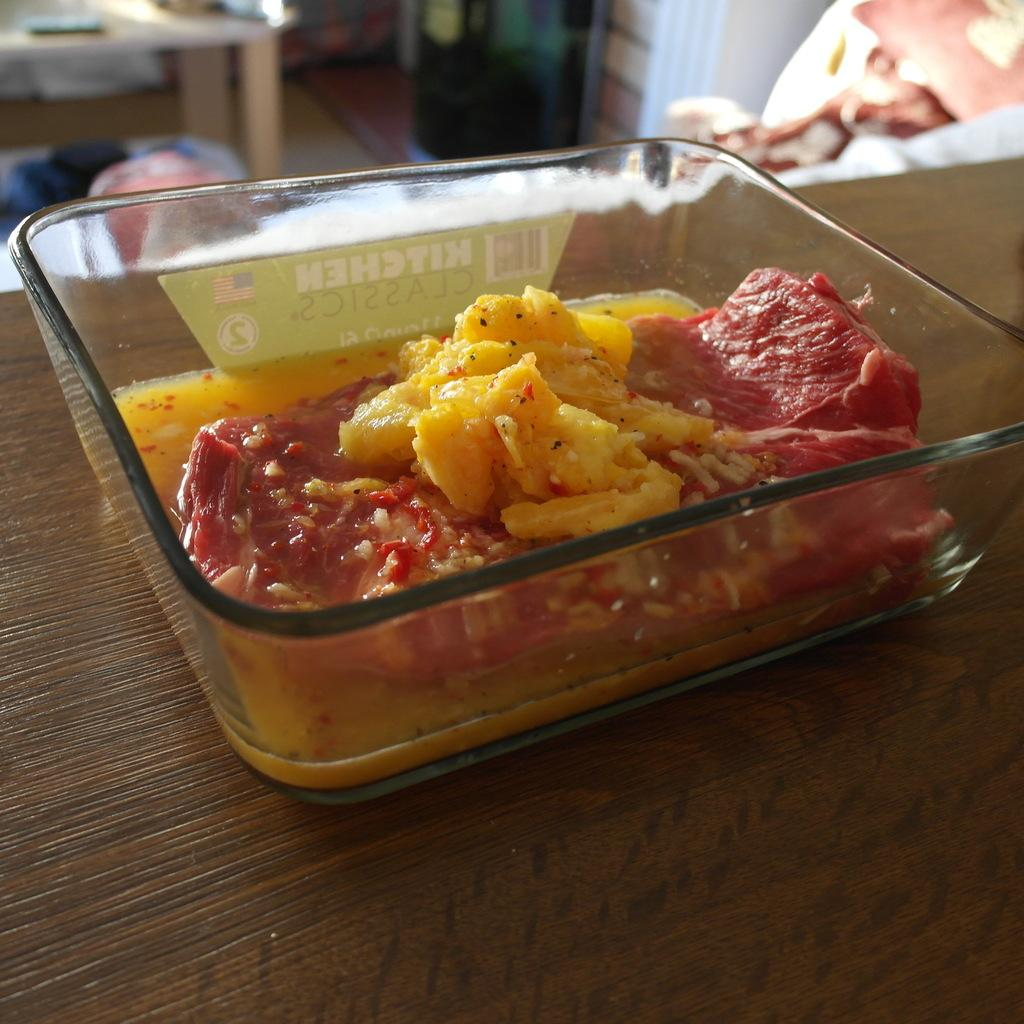What type of food item is in the glass container? The specific type of food item is not mentioned in the facts, but it is in a glass container. Where is the glass container placed? The glass container is on a wooden surface. What is the primary piece of furniture in the image? There is a table in the image. What can be seen at the top of the image? There are objects visible at the top of the image. What type of brush is being used to paint the wren in the image? There is no brush or wren present in the image. 